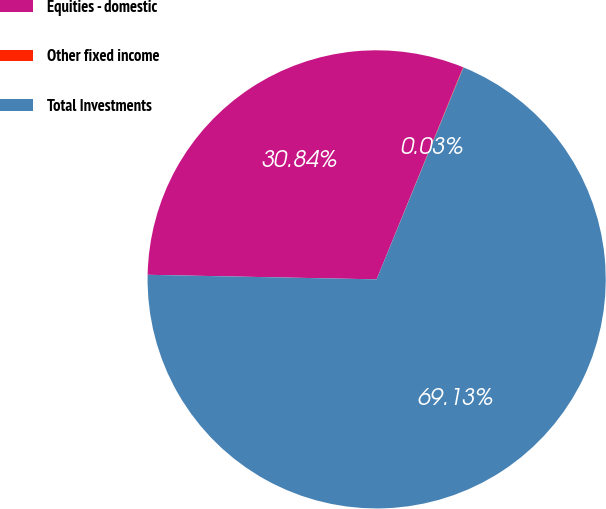Convert chart to OTSL. <chart><loc_0><loc_0><loc_500><loc_500><pie_chart><fcel>Equities - domestic<fcel>Other fixed income<fcel>Total Investments<nl><fcel>30.84%<fcel>0.03%<fcel>69.13%<nl></chart> 